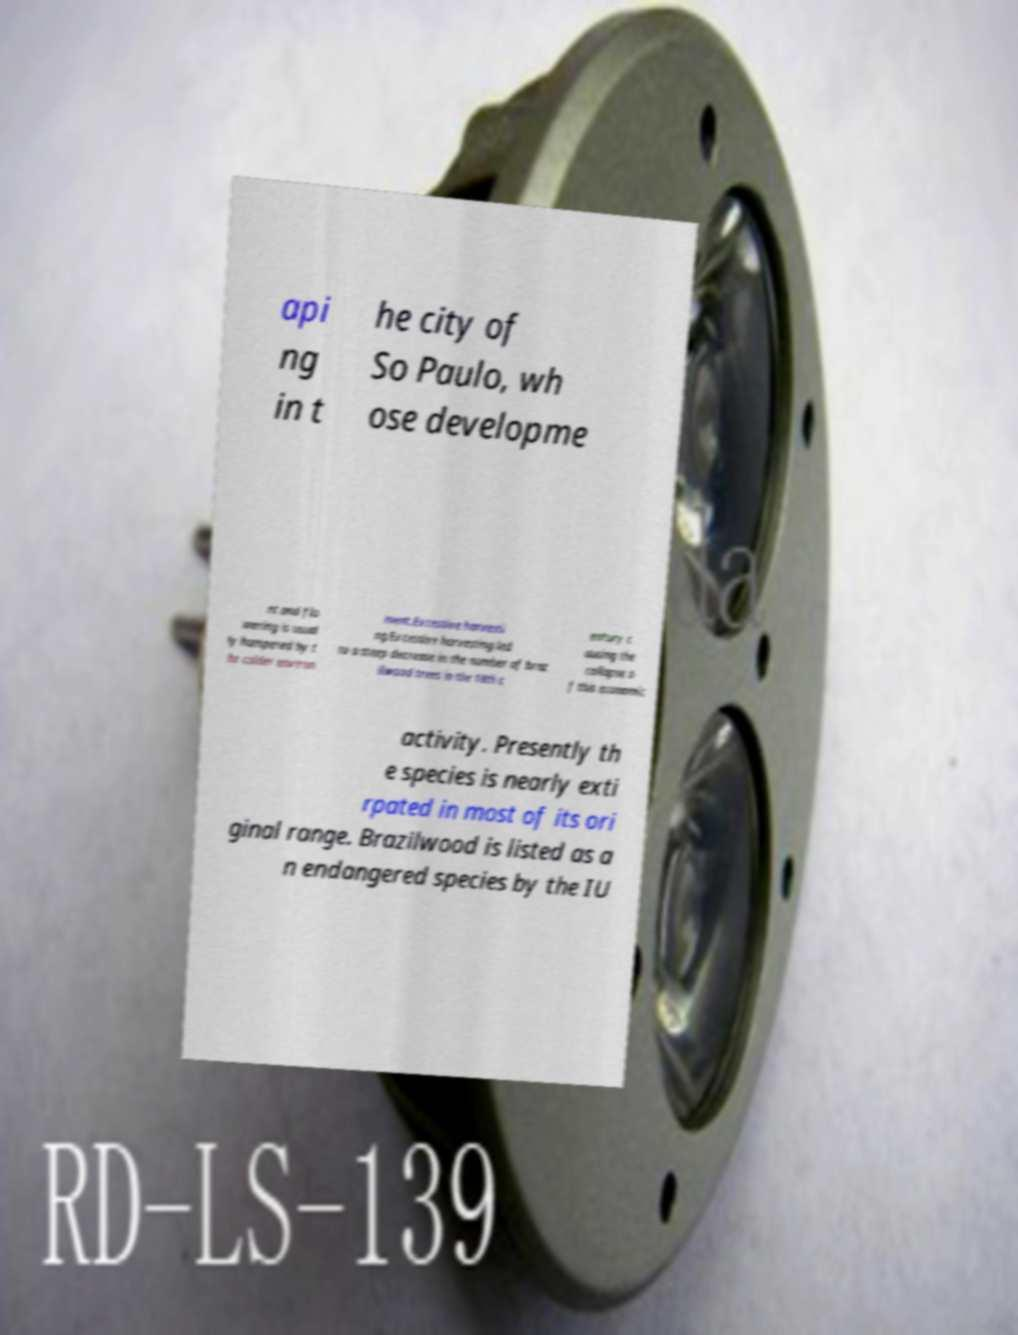Please identify and transcribe the text found in this image. api ng in t he city of So Paulo, wh ose developme nt and flo wering is usual ly hampered by t he colder environ ment.Excessive harvesti ng.Excessive harvesting led to a steep decrease in the number of braz ilwood trees in the 18th c entury c ausing the collapse o f this economic activity. Presently th e species is nearly exti rpated in most of its ori ginal range. Brazilwood is listed as a n endangered species by the IU 